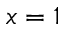Convert formula to latex. <formula><loc_0><loc_0><loc_500><loc_500>x = 1</formula> 